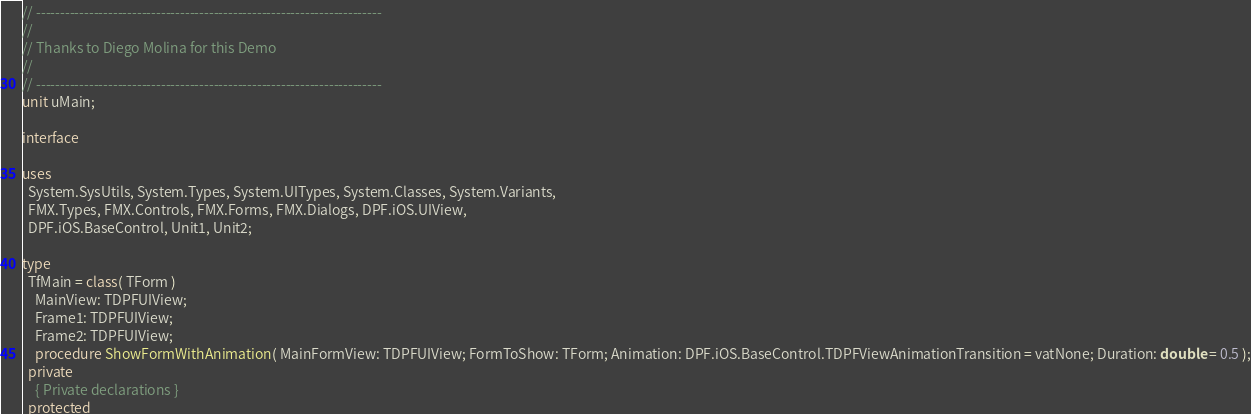<code> <loc_0><loc_0><loc_500><loc_500><_Pascal_>// ------------------------------------------------------------------------
//
// Thanks to Diego Molina for this Demo
//
// ------------------------------------------------------------------------
unit uMain;

interface

uses
  System.SysUtils, System.Types, System.UITypes, System.Classes, System.Variants,
  FMX.Types, FMX.Controls, FMX.Forms, FMX.Dialogs, DPF.iOS.UIView,
  DPF.iOS.BaseControl, Unit1, Unit2;

type
  TfMain = class( TForm )
    MainView: TDPFUIView;
    Frame1: TDPFUIView;
    Frame2: TDPFUIView;
    procedure ShowFormWithAnimation( MainFormView: TDPFUIView; FormToShow: TForm; Animation: DPF.iOS.BaseControl.TDPFViewAnimationTransition = vatNone; Duration: double = 0.5 );
  private
    { Private declarations }
  protected</code> 